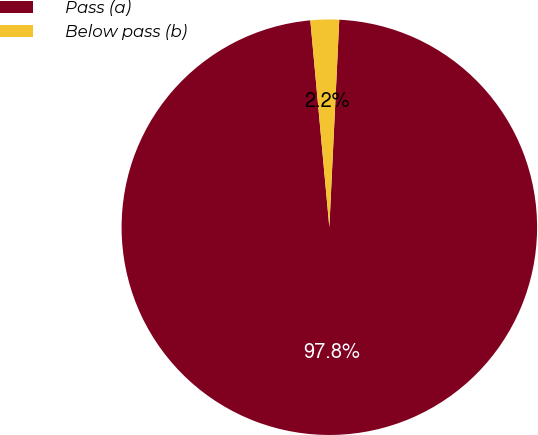Convert chart. <chart><loc_0><loc_0><loc_500><loc_500><pie_chart><fcel>Pass (a)<fcel>Below pass (b)<nl><fcel>97.78%<fcel>2.22%<nl></chart> 